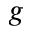<formula> <loc_0><loc_0><loc_500><loc_500>^ { g }</formula> 